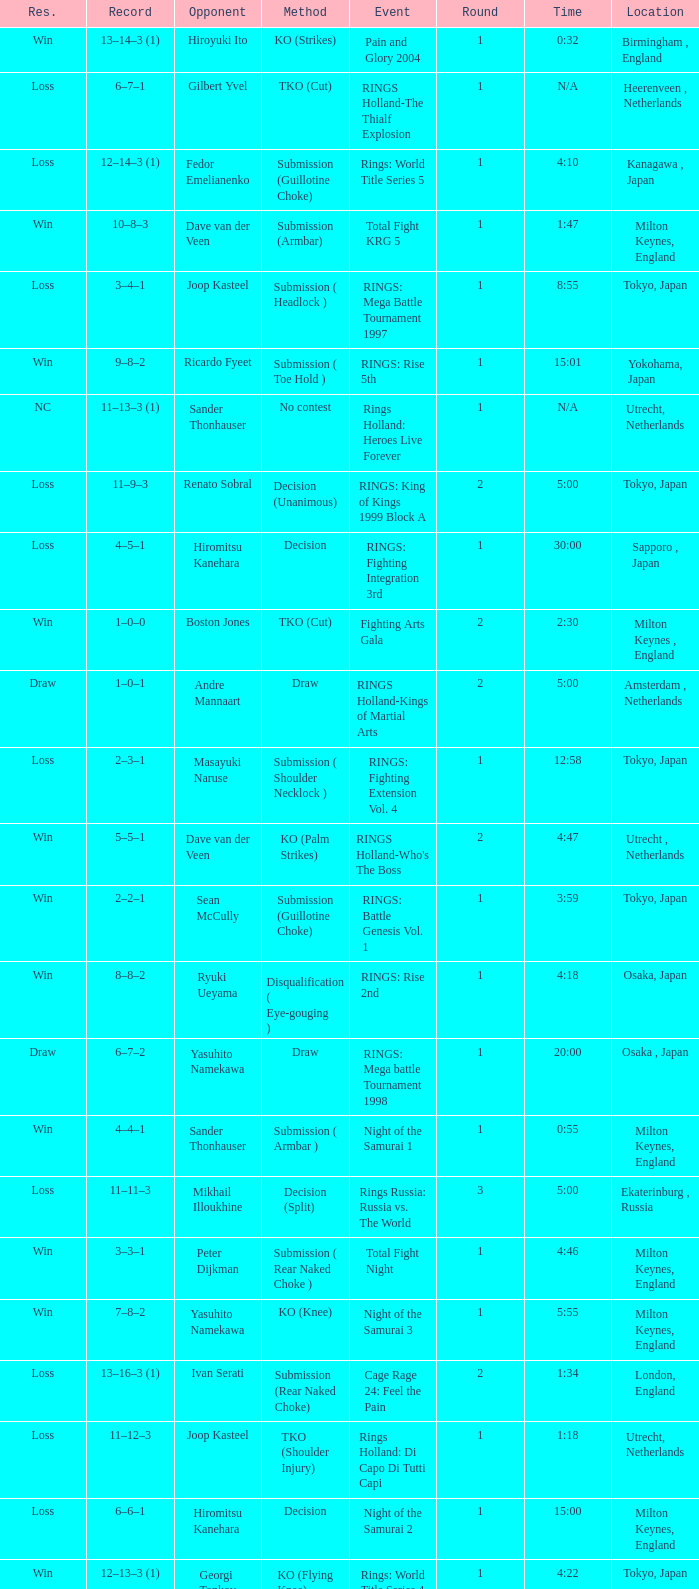What is the time for Moscow, Russia? N/A. 